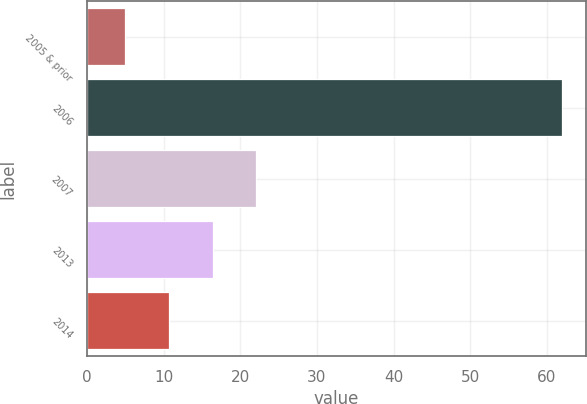<chart> <loc_0><loc_0><loc_500><loc_500><bar_chart><fcel>2005 & prior<fcel>2006<fcel>2007<fcel>2013<fcel>2014<nl><fcel>5<fcel>62<fcel>22.1<fcel>16.4<fcel>10.7<nl></chart> 